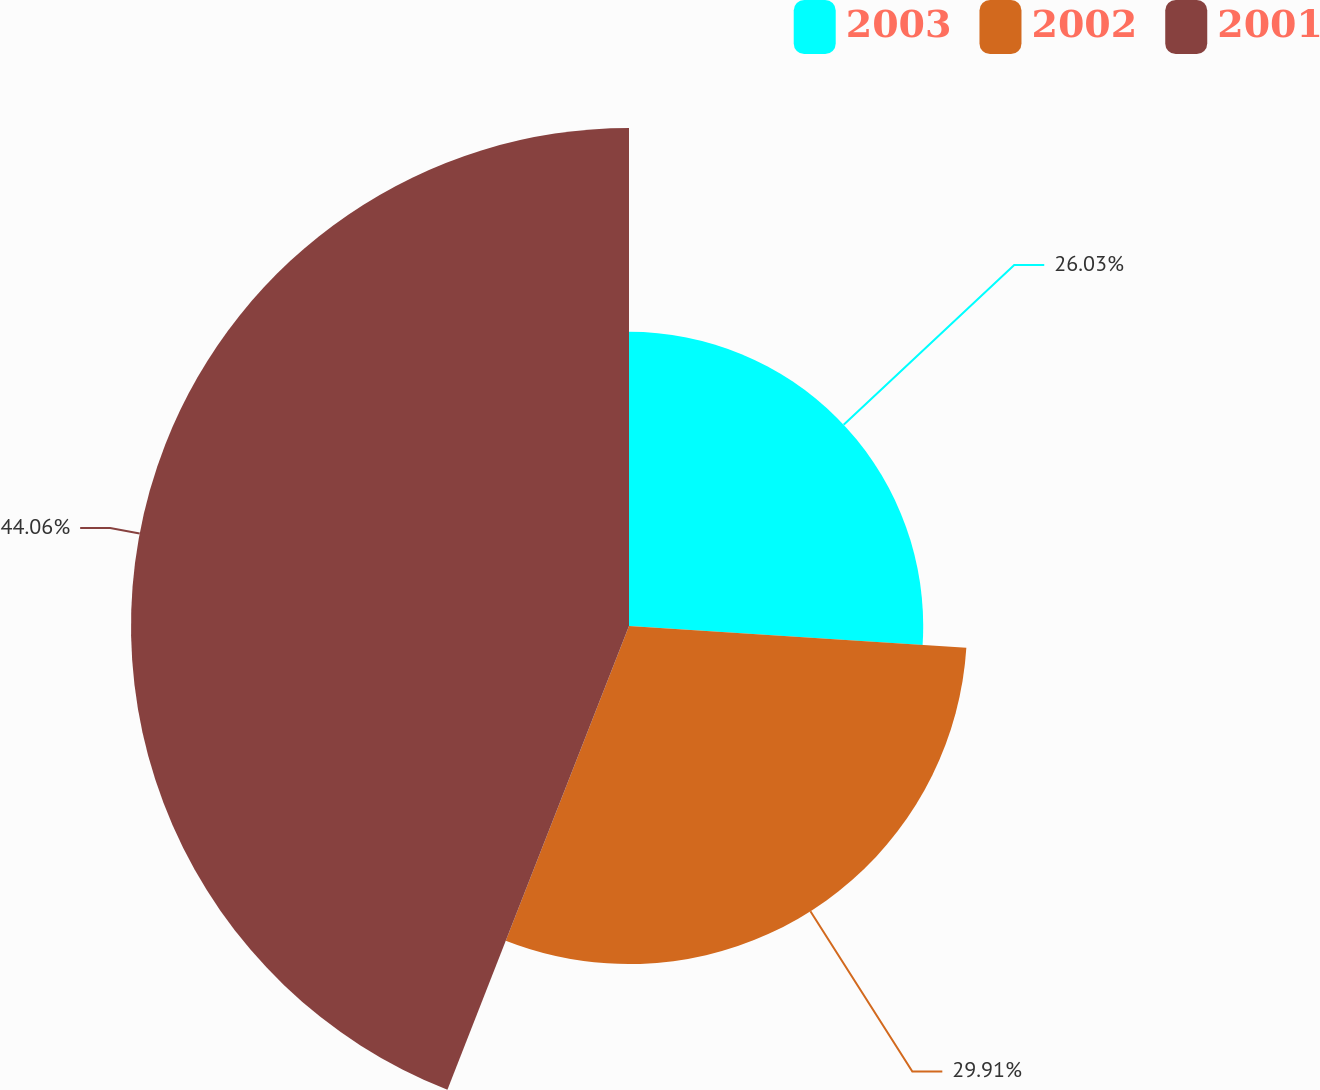Convert chart. <chart><loc_0><loc_0><loc_500><loc_500><pie_chart><fcel>2003<fcel>2002<fcel>2001<nl><fcel>26.03%<fcel>29.91%<fcel>44.06%<nl></chart> 